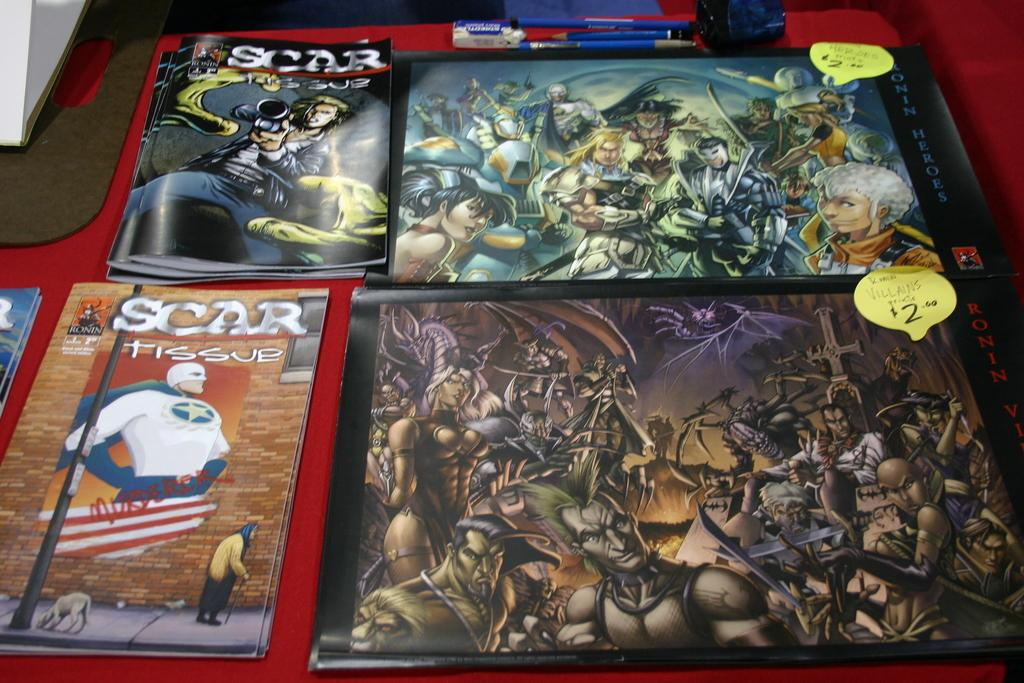What stationery items can be seen in the image? There are pens and a rubber in the image. What surface are the items placed on? The objects are on a table. What type of paper is present in the image? There is a writing pad in the image. What can be found on the books in the image? There are books with images in the image, and they have price tags on them. How many kittens are playing with a feather on the table in the image? There are no kittens or feathers present in the image; it only features stationery items and books. What type of stocking is visible on the table in the image? There is no stocking present in the image. 